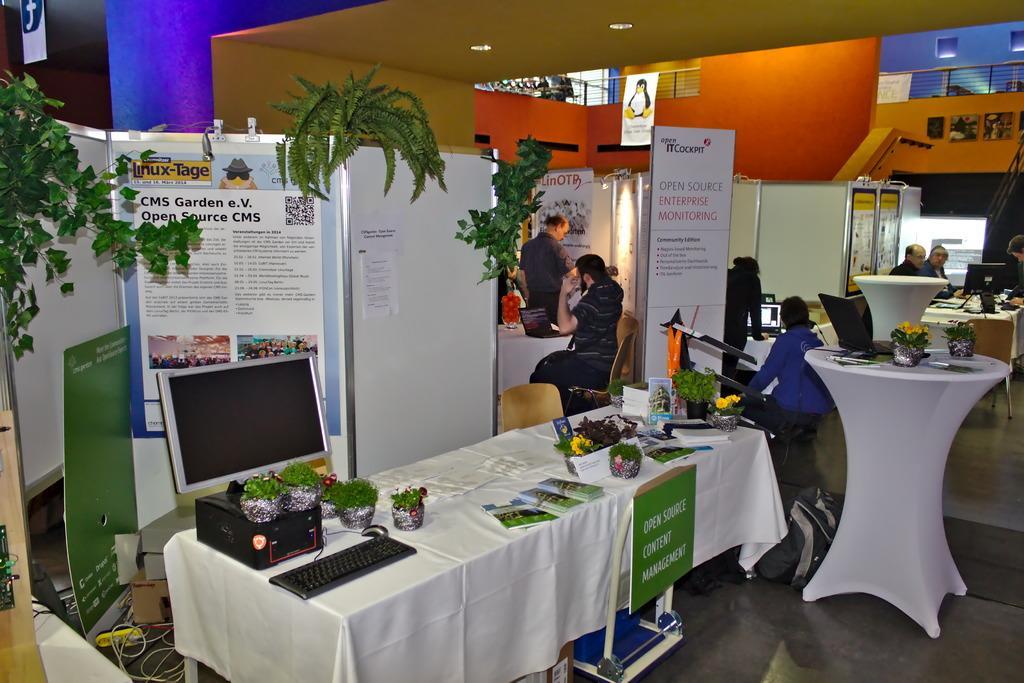In one or two sentences, can you explain what this image depicts? In this picture we can see some people are sitting and some people are standing. On the left side of the people there are boards, houseplants, chair and a table covered with a cloth. On the table there is a keyboard, decorative plants, monitor, some pamphlets and other things. Behind the people there is a wall and a paper. 